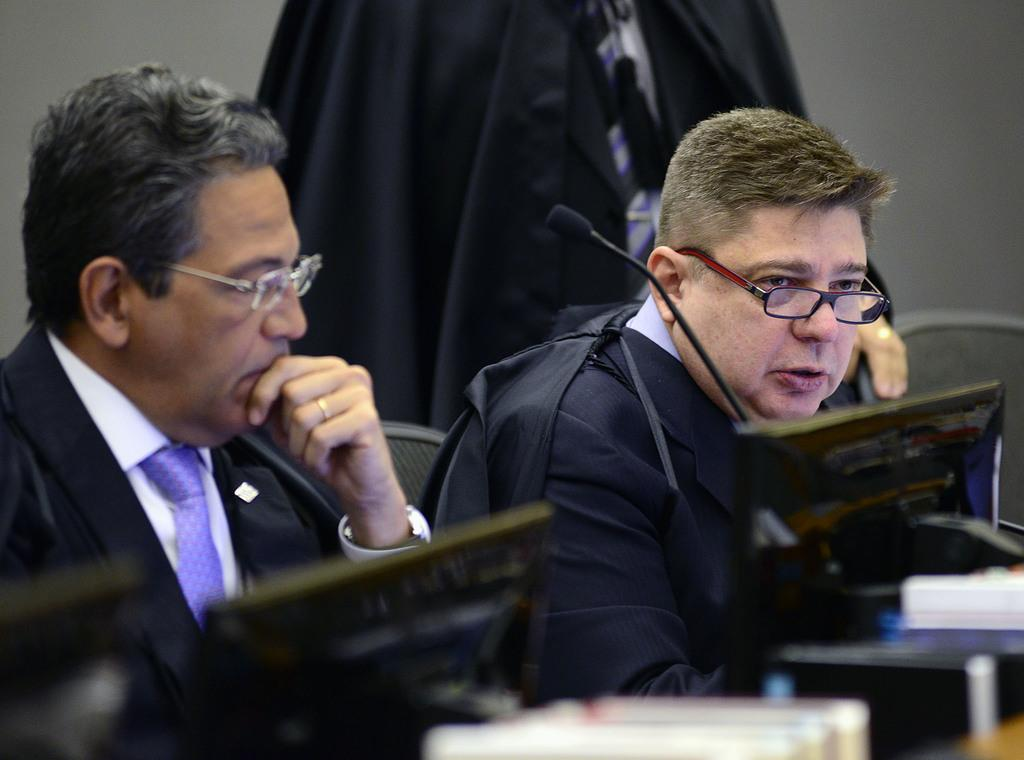How many people are in the image? There are three persons in the image. What are the people wearing? The persons are wearing black color jackets. What object can be seen in the image besides the people? There is a table in the image. What is on the table? There are screens on the table. Can you see any babies playing with a spade in the image? There are no babies or spades present in the image. Is there any blood visible on the persons' jackets in the image? There is no blood visible on the persons' jackets in the image. 